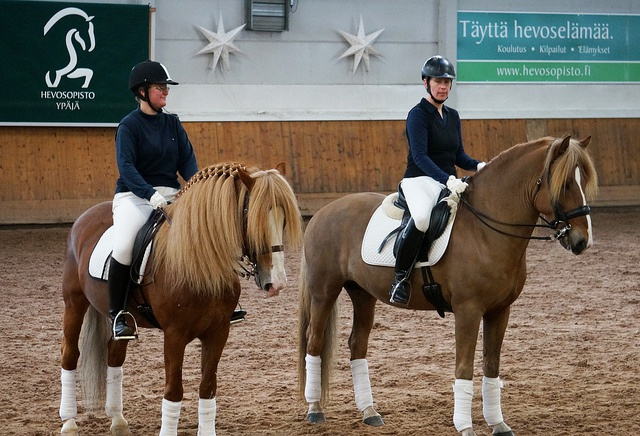Describe the objects in this image and their specific colors. I can see horse in black, maroon, and gray tones, people in black, lightgray, darkgray, and navy tones, and people in black, lightgray, navy, and gray tones in this image. 